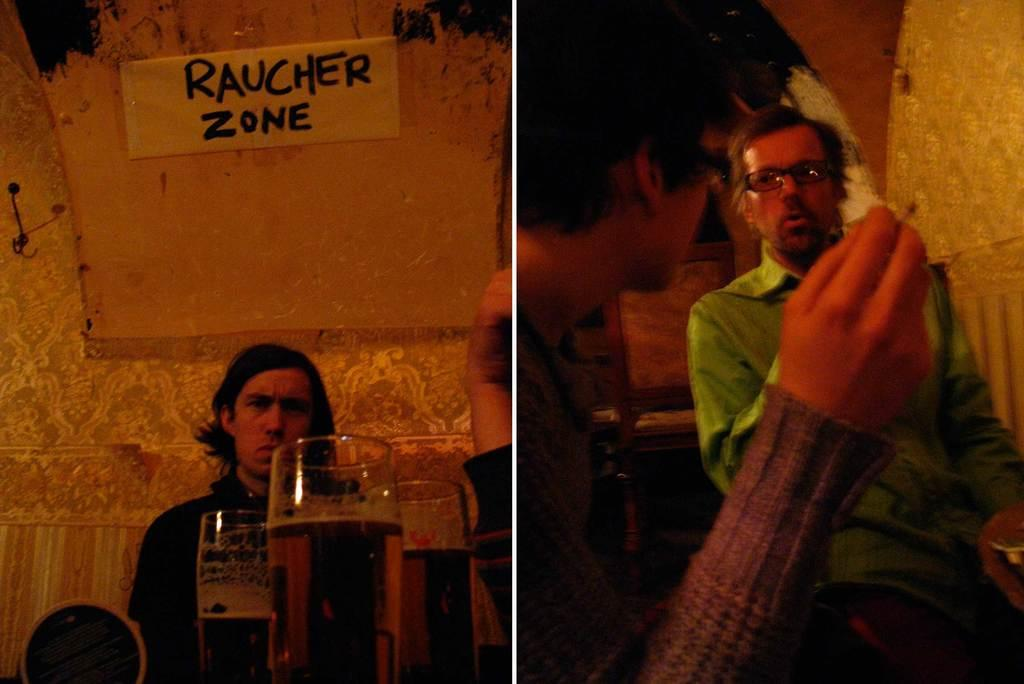<image>
Give a short and clear explanation of the subsequent image. A few split photos are showing a few men being serious and the sign on the left picture says RAUCHER ZONE. 